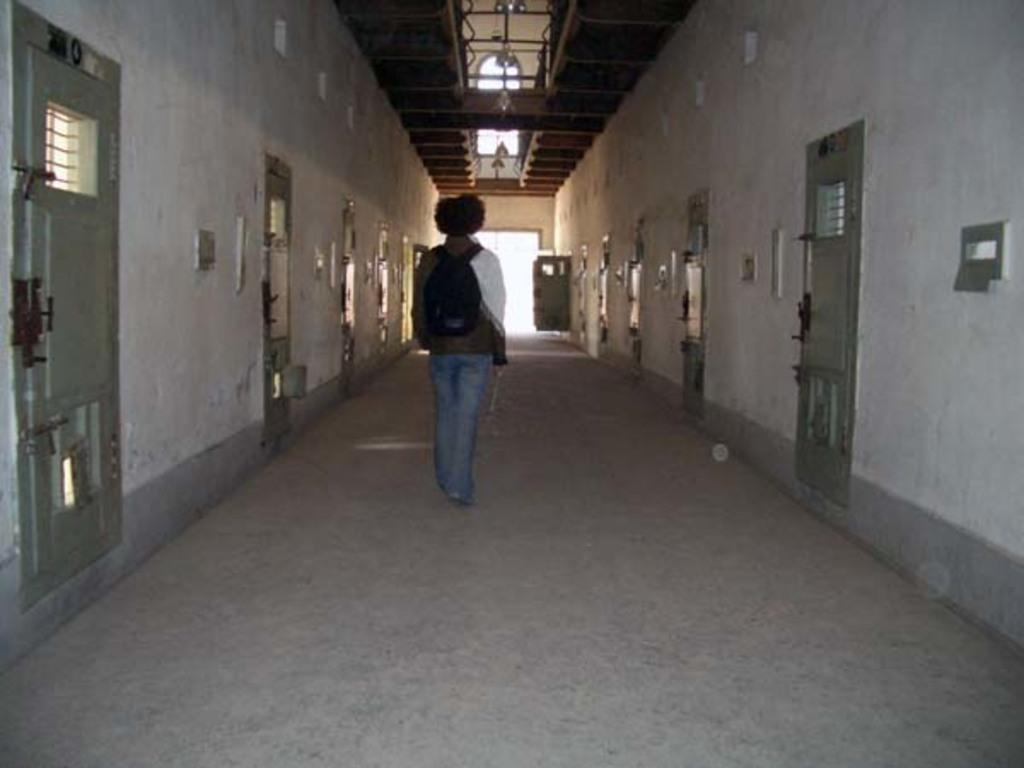What is the person in the image doing? The person is walking in the image. Where is the person walking? The person is in a corridor. What can be seen on either side of the person? There are doors on either side of the person. What is located at the top of the image? There is a metal structure at the top of the image. What type of machine can be seen in the park in the image? There is no machine or park present in the image; it features a person walking in a corridor with doors on either side and a metal structure at the top. 